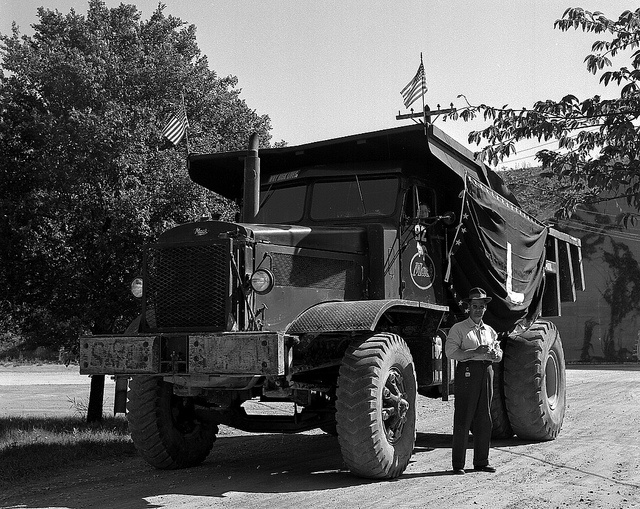Describe the objects in this image and their specific colors. I can see truck in lightgray, black, gray, and darkgray tones and people in lightgray, black, gray, and darkgray tones in this image. 